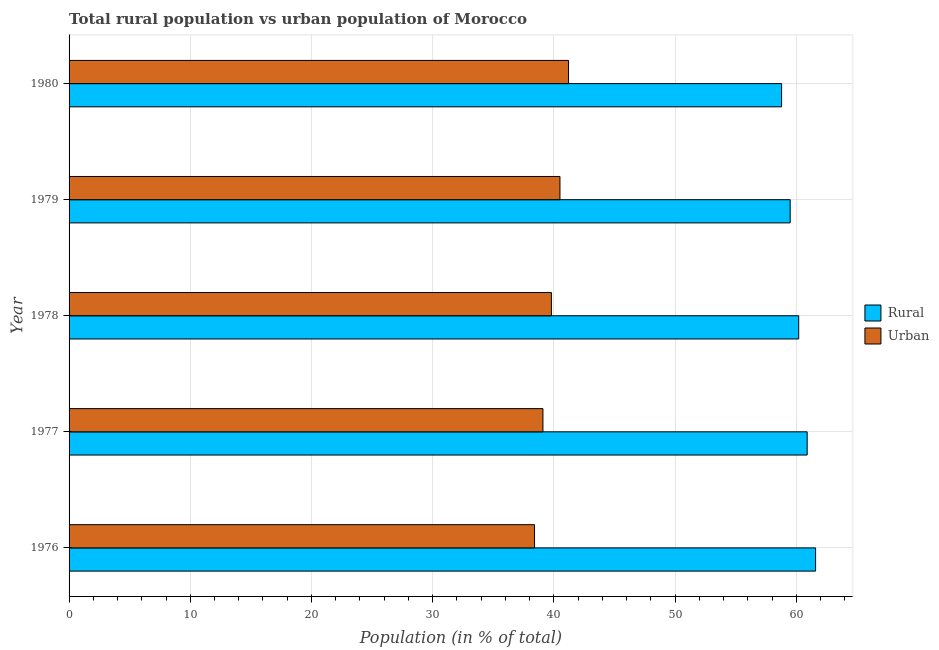How many different coloured bars are there?
Your response must be concise. 2. How many groups of bars are there?
Provide a succinct answer. 5. Are the number of bars on each tick of the Y-axis equal?
Make the answer very short. Yes. How many bars are there on the 2nd tick from the bottom?
Keep it short and to the point. 2. What is the label of the 2nd group of bars from the top?
Your answer should be compact. 1979. What is the rural population in 1978?
Ensure brevity in your answer.  60.2. Across all years, what is the maximum rural population?
Keep it short and to the point. 61.59. Across all years, what is the minimum urban population?
Make the answer very short. 38.41. In which year was the urban population maximum?
Keep it short and to the point. 1980. What is the total urban population in the graph?
Make the answer very short. 199.01. What is the difference between the urban population in 1976 and that in 1977?
Keep it short and to the point. -0.69. What is the difference between the urban population in 1976 and the rural population in 1977?
Keep it short and to the point. -22.5. What is the average rural population per year?
Offer a very short reply. 60.2. In the year 1977, what is the difference between the rural population and urban population?
Your answer should be compact. 21.8. In how many years, is the urban population greater than 50 %?
Provide a short and direct response. 0. Is the rural population in 1976 less than that in 1979?
Your answer should be compact. No. Is the difference between the rural population in 1977 and 1979 greater than the difference between the urban population in 1977 and 1979?
Provide a short and direct response. Yes. What is the difference between the highest and the second highest rural population?
Offer a very short reply. 0.69. What is the difference between the highest and the lowest urban population?
Keep it short and to the point. 2.8. Is the sum of the rural population in 1977 and 1978 greater than the maximum urban population across all years?
Your response must be concise. Yes. What does the 1st bar from the top in 1976 represents?
Your response must be concise. Urban. What does the 2nd bar from the bottom in 1977 represents?
Offer a terse response. Urban. Does the graph contain any zero values?
Provide a short and direct response. No. Where does the legend appear in the graph?
Your answer should be compact. Center right. How are the legend labels stacked?
Your response must be concise. Vertical. What is the title of the graph?
Keep it short and to the point. Total rural population vs urban population of Morocco. What is the label or title of the X-axis?
Offer a terse response. Population (in % of total). What is the Population (in % of total) in Rural in 1976?
Offer a very short reply. 61.59. What is the Population (in % of total) of Urban in 1976?
Ensure brevity in your answer.  38.41. What is the Population (in % of total) in Rural in 1977?
Offer a terse response. 60.9. What is the Population (in % of total) in Urban in 1977?
Give a very brief answer. 39.1. What is the Population (in % of total) in Rural in 1978?
Your response must be concise. 60.2. What is the Population (in % of total) of Urban in 1978?
Ensure brevity in your answer.  39.8. What is the Population (in % of total) of Rural in 1979?
Your answer should be very brief. 59.5. What is the Population (in % of total) in Urban in 1979?
Ensure brevity in your answer.  40.5. What is the Population (in % of total) of Rural in 1980?
Give a very brief answer. 58.79. What is the Population (in % of total) of Urban in 1980?
Your answer should be very brief. 41.21. Across all years, what is the maximum Population (in % of total) of Rural?
Provide a succinct answer. 61.59. Across all years, what is the maximum Population (in % of total) in Urban?
Offer a terse response. 41.21. Across all years, what is the minimum Population (in % of total) of Rural?
Keep it short and to the point. 58.79. Across all years, what is the minimum Population (in % of total) in Urban?
Your answer should be very brief. 38.41. What is the total Population (in % of total) in Rural in the graph?
Keep it short and to the point. 300.99. What is the total Population (in % of total) in Urban in the graph?
Offer a very short reply. 199.01. What is the difference between the Population (in % of total) of Rural in 1976 and that in 1977?
Offer a very short reply. 0.69. What is the difference between the Population (in % of total) of Urban in 1976 and that in 1977?
Ensure brevity in your answer.  -0.69. What is the difference between the Population (in % of total) of Rural in 1976 and that in 1978?
Offer a terse response. 1.39. What is the difference between the Population (in % of total) of Urban in 1976 and that in 1978?
Ensure brevity in your answer.  -1.39. What is the difference between the Population (in % of total) in Rural in 1976 and that in 1979?
Ensure brevity in your answer.  2.1. What is the difference between the Population (in % of total) of Urban in 1976 and that in 1979?
Provide a succinct answer. -2.1. What is the difference between the Population (in % of total) of Rural in 1976 and that in 1980?
Provide a short and direct response. 2.81. What is the difference between the Population (in % of total) of Urban in 1976 and that in 1980?
Offer a very short reply. -2.81. What is the difference between the Population (in % of total) in Rural in 1977 and that in 1978?
Your answer should be compact. 0.7. What is the difference between the Population (in % of total) of Urban in 1977 and that in 1978?
Your answer should be compact. -0.7. What is the difference between the Population (in % of total) in Rural in 1977 and that in 1979?
Give a very brief answer. 1.4. What is the difference between the Population (in % of total) in Urban in 1977 and that in 1979?
Offer a very short reply. -1.4. What is the difference between the Population (in % of total) of Rural in 1977 and that in 1980?
Offer a very short reply. 2.11. What is the difference between the Population (in % of total) in Urban in 1977 and that in 1980?
Make the answer very short. -2.11. What is the difference between the Population (in % of total) in Rural in 1978 and that in 1979?
Provide a succinct answer. 0.7. What is the difference between the Population (in % of total) in Urban in 1978 and that in 1979?
Provide a succinct answer. -0.7. What is the difference between the Population (in % of total) of Rural in 1978 and that in 1980?
Provide a short and direct response. 1.41. What is the difference between the Population (in % of total) of Urban in 1978 and that in 1980?
Your response must be concise. -1.41. What is the difference between the Population (in % of total) in Rural in 1979 and that in 1980?
Offer a very short reply. 0.71. What is the difference between the Population (in % of total) in Urban in 1979 and that in 1980?
Ensure brevity in your answer.  -0.71. What is the difference between the Population (in % of total) of Rural in 1976 and the Population (in % of total) of Urban in 1977?
Ensure brevity in your answer.  22.5. What is the difference between the Population (in % of total) of Rural in 1976 and the Population (in % of total) of Urban in 1978?
Offer a terse response. 21.8. What is the difference between the Population (in % of total) in Rural in 1976 and the Population (in % of total) in Urban in 1979?
Your response must be concise. 21.09. What is the difference between the Population (in % of total) in Rural in 1976 and the Population (in % of total) in Urban in 1980?
Make the answer very short. 20.39. What is the difference between the Population (in % of total) in Rural in 1977 and the Population (in % of total) in Urban in 1978?
Make the answer very short. 21.1. What is the difference between the Population (in % of total) in Rural in 1977 and the Population (in % of total) in Urban in 1979?
Provide a short and direct response. 20.4. What is the difference between the Population (in % of total) in Rural in 1977 and the Population (in % of total) in Urban in 1980?
Give a very brief answer. 19.69. What is the difference between the Population (in % of total) in Rural in 1978 and the Population (in % of total) in Urban in 1979?
Your response must be concise. 19.7. What is the difference between the Population (in % of total) of Rural in 1978 and the Population (in % of total) of Urban in 1980?
Give a very brief answer. 18.99. What is the difference between the Population (in % of total) of Rural in 1979 and the Population (in % of total) of Urban in 1980?
Offer a very short reply. 18.29. What is the average Population (in % of total) in Rural per year?
Provide a succinct answer. 60.2. What is the average Population (in % of total) of Urban per year?
Offer a terse response. 39.8. In the year 1976, what is the difference between the Population (in % of total) in Rural and Population (in % of total) in Urban?
Your answer should be compact. 23.19. In the year 1977, what is the difference between the Population (in % of total) in Rural and Population (in % of total) in Urban?
Your response must be concise. 21.8. In the year 1978, what is the difference between the Population (in % of total) in Rural and Population (in % of total) in Urban?
Offer a very short reply. 20.4. In the year 1979, what is the difference between the Population (in % of total) of Rural and Population (in % of total) of Urban?
Your answer should be compact. 19. In the year 1980, what is the difference between the Population (in % of total) in Rural and Population (in % of total) in Urban?
Ensure brevity in your answer.  17.58. What is the ratio of the Population (in % of total) in Rural in 1976 to that in 1977?
Provide a short and direct response. 1.01. What is the ratio of the Population (in % of total) of Urban in 1976 to that in 1977?
Offer a terse response. 0.98. What is the ratio of the Population (in % of total) of Rural in 1976 to that in 1978?
Offer a terse response. 1.02. What is the ratio of the Population (in % of total) in Urban in 1976 to that in 1978?
Keep it short and to the point. 0.96. What is the ratio of the Population (in % of total) of Rural in 1976 to that in 1979?
Your answer should be compact. 1.04. What is the ratio of the Population (in % of total) in Urban in 1976 to that in 1979?
Offer a terse response. 0.95. What is the ratio of the Population (in % of total) of Rural in 1976 to that in 1980?
Give a very brief answer. 1.05. What is the ratio of the Population (in % of total) of Urban in 1976 to that in 1980?
Provide a succinct answer. 0.93. What is the ratio of the Population (in % of total) of Rural in 1977 to that in 1978?
Make the answer very short. 1.01. What is the ratio of the Population (in % of total) in Urban in 1977 to that in 1978?
Keep it short and to the point. 0.98. What is the ratio of the Population (in % of total) in Rural in 1977 to that in 1979?
Your answer should be very brief. 1.02. What is the ratio of the Population (in % of total) of Urban in 1977 to that in 1979?
Your answer should be very brief. 0.97. What is the ratio of the Population (in % of total) of Rural in 1977 to that in 1980?
Give a very brief answer. 1.04. What is the ratio of the Population (in % of total) of Urban in 1977 to that in 1980?
Provide a succinct answer. 0.95. What is the ratio of the Population (in % of total) of Rural in 1978 to that in 1979?
Give a very brief answer. 1.01. What is the ratio of the Population (in % of total) of Urban in 1978 to that in 1979?
Your answer should be very brief. 0.98. What is the ratio of the Population (in % of total) of Urban in 1978 to that in 1980?
Make the answer very short. 0.97. What is the ratio of the Population (in % of total) in Urban in 1979 to that in 1980?
Your response must be concise. 0.98. What is the difference between the highest and the second highest Population (in % of total) in Rural?
Your answer should be very brief. 0.69. What is the difference between the highest and the second highest Population (in % of total) of Urban?
Ensure brevity in your answer.  0.71. What is the difference between the highest and the lowest Population (in % of total) of Rural?
Offer a terse response. 2.81. What is the difference between the highest and the lowest Population (in % of total) of Urban?
Your answer should be compact. 2.81. 